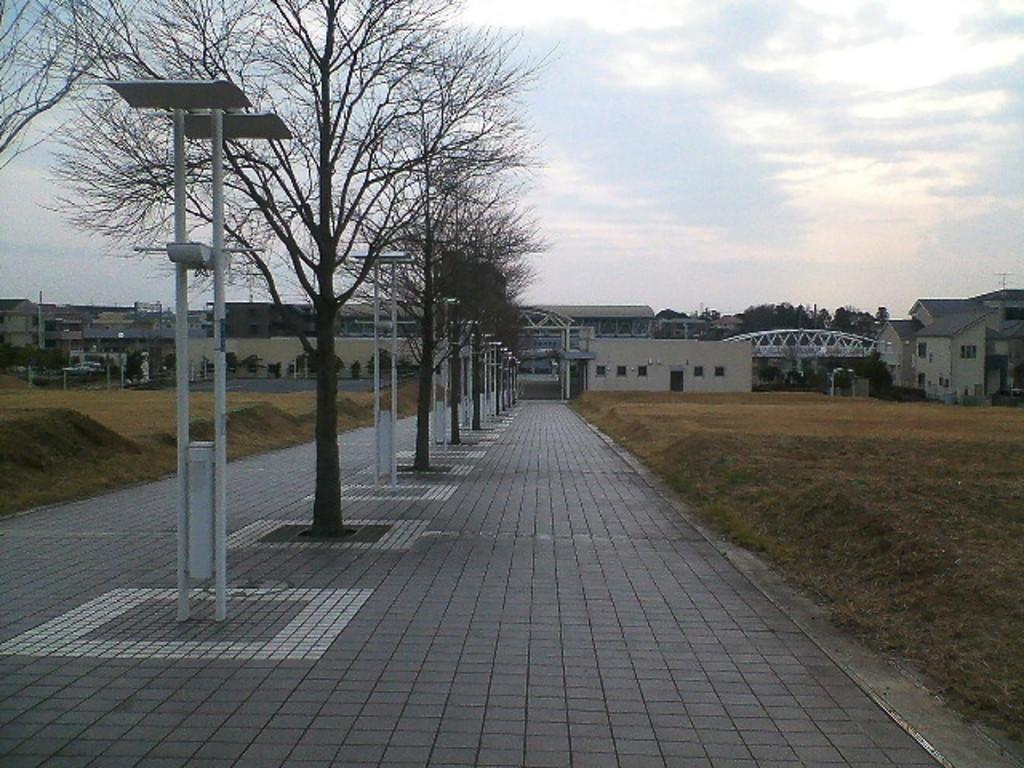What type of surface is visible in the image? There is a pavement in the image. What can be seen in the middle of the image? There are poles and trees in the middle of the image. What type of vegetation is present on either side of the pavement? There is grassland on either side of the pavement. What is visible in the background of the image? There are buildings and the sky visible in the background of the image. What type of science experiment is being conducted on the pavement in the image? There is no science experiment visible in the image; it only shows a pavement, poles, trees, grassland, buildings, and the sky. 